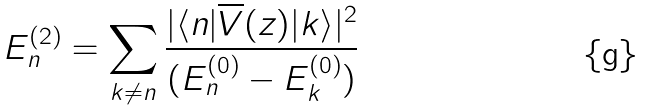Convert formula to latex. <formula><loc_0><loc_0><loc_500><loc_500>E _ { n } ^ { ( 2 ) } = \sum _ { k \neq n } \frac { | \langle n | \overline { V } ( z ) | k \rangle | ^ { 2 } } { ( E _ { n } ^ { ( 0 ) } - E _ { k } ^ { ( 0 ) } ) }</formula> 